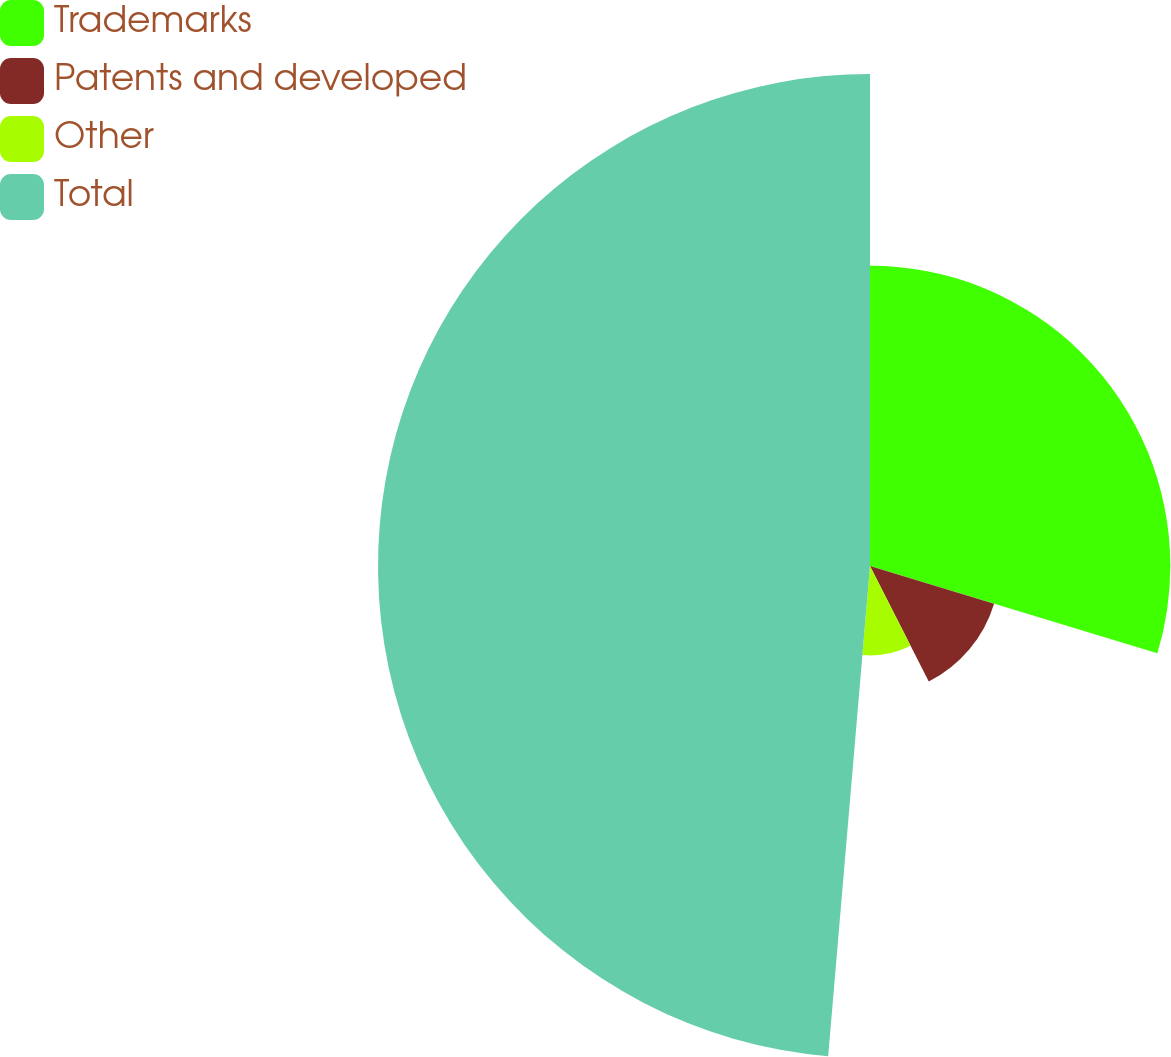Convert chart. <chart><loc_0><loc_0><loc_500><loc_500><pie_chart><fcel>Trademarks<fcel>Patents and developed<fcel>Other<fcel>Total<nl><fcel>29.69%<fcel>12.82%<fcel>8.84%<fcel>48.64%<nl></chart> 